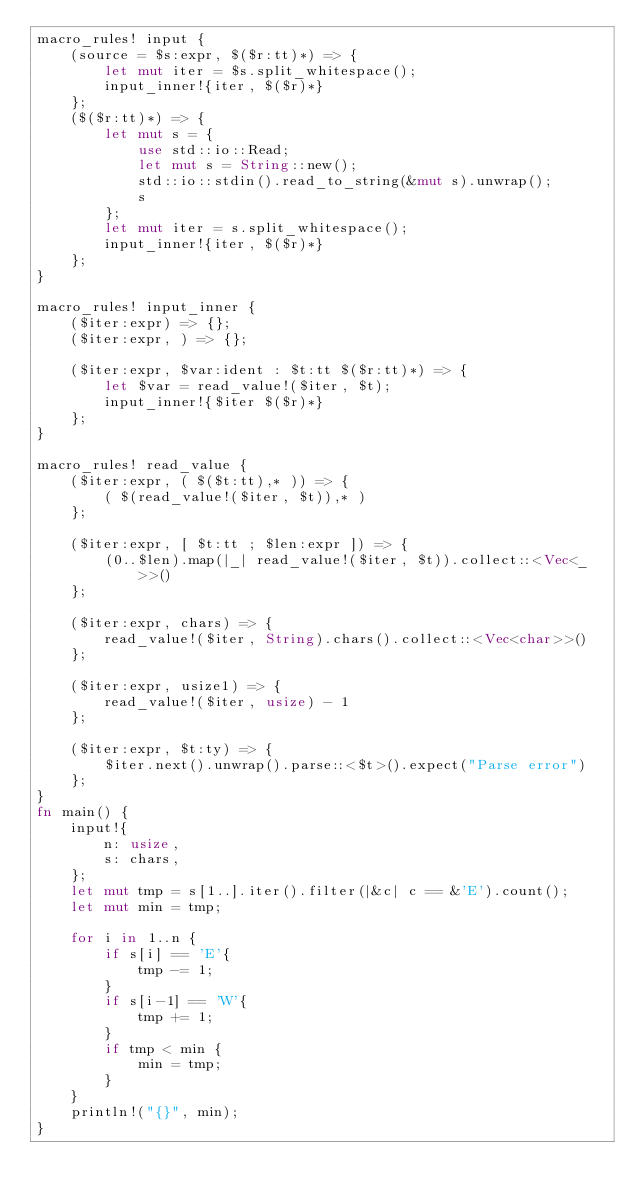Convert code to text. <code><loc_0><loc_0><loc_500><loc_500><_Rust_>macro_rules! input {
    (source = $s:expr, $($r:tt)*) => {
        let mut iter = $s.split_whitespace();
        input_inner!{iter, $($r)*}
    };
    ($($r:tt)*) => {
        let mut s = {
            use std::io::Read;
            let mut s = String::new();
            std::io::stdin().read_to_string(&mut s).unwrap();
            s
        };
        let mut iter = s.split_whitespace();
        input_inner!{iter, $($r)*}
    };
}

macro_rules! input_inner {
    ($iter:expr) => {};
    ($iter:expr, ) => {};

    ($iter:expr, $var:ident : $t:tt $($r:tt)*) => {
        let $var = read_value!($iter, $t);
        input_inner!{$iter $($r)*}
    };
}

macro_rules! read_value {
    ($iter:expr, ( $($t:tt),* )) => {
        ( $(read_value!($iter, $t)),* )
    };

    ($iter:expr, [ $t:tt ; $len:expr ]) => {
        (0..$len).map(|_| read_value!($iter, $t)).collect::<Vec<_>>()
    };

    ($iter:expr, chars) => {
        read_value!($iter, String).chars().collect::<Vec<char>>()
    };

    ($iter:expr, usize1) => {
        read_value!($iter, usize) - 1
    };

    ($iter:expr, $t:ty) => {
        $iter.next().unwrap().parse::<$t>().expect("Parse error")
    };
}
fn main() {
    input!{
        n: usize,
        s: chars,
    };
    let mut tmp = s[1..].iter().filter(|&c| c == &'E').count();
    let mut min = tmp;

    for i in 1..n {
        if s[i] == 'E'{
            tmp -= 1;
        }
        if s[i-1] == 'W'{
            tmp += 1;
        }
        if tmp < min {
            min = tmp;
        }
    }
    println!("{}", min);
}
</code> 